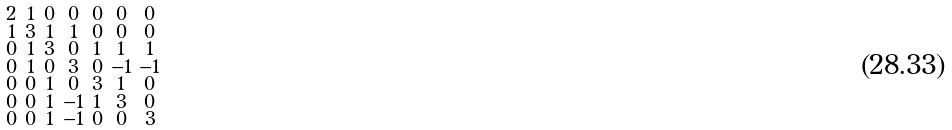<formula> <loc_0><loc_0><loc_500><loc_500>\begin{smallmatrix} 2 & 1 & 0 & 0 & 0 & 0 & 0 \\ 1 & 3 & 1 & 1 & 0 & 0 & 0 \\ 0 & 1 & 3 & 0 & 1 & 1 & 1 \\ 0 & 1 & 0 & 3 & 0 & - 1 & - 1 \\ 0 & 0 & 1 & 0 & 3 & 1 & 0 \\ 0 & 0 & 1 & - 1 & 1 & 3 & 0 \\ 0 & 0 & 1 & - 1 & 0 & 0 & 3 \end{smallmatrix}</formula> 